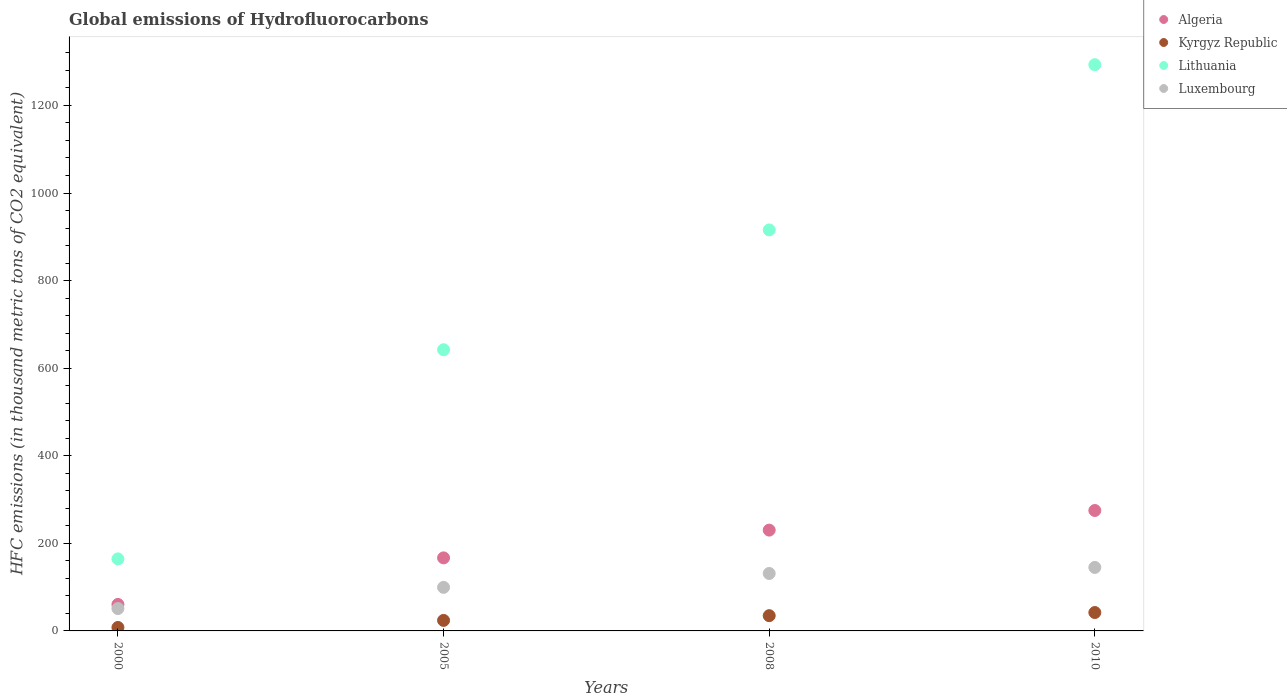Is the number of dotlines equal to the number of legend labels?
Your answer should be very brief. Yes. What is the global emissions of Hydrofluorocarbons in Algeria in 2008?
Make the answer very short. 230.2. Across all years, what is the maximum global emissions of Hydrofluorocarbons in Luxembourg?
Keep it short and to the point. 145. In which year was the global emissions of Hydrofluorocarbons in Luxembourg maximum?
Offer a very short reply. 2010. In which year was the global emissions of Hydrofluorocarbons in Algeria minimum?
Offer a very short reply. 2000. What is the total global emissions of Hydrofluorocarbons in Luxembourg in the graph?
Your response must be concise. 426.8. What is the difference between the global emissions of Hydrofluorocarbons in Kyrgyz Republic in 2000 and that in 2005?
Give a very brief answer. -16.1. What is the difference between the global emissions of Hydrofluorocarbons in Kyrgyz Republic in 2005 and the global emissions of Hydrofluorocarbons in Luxembourg in 2010?
Make the answer very short. -121. What is the average global emissions of Hydrofluorocarbons in Lithuania per year?
Ensure brevity in your answer.  753.83. In the year 2000, what is the difference between the global emissions of Hydrofluorocarbons in Luxembourg and global emissions of Hydrofluorocarbons in Kyrgyz Republic?
Your answer should be very brief. 43.2. In how many years, is the global emissions of Hydrofluorocarbons in Algeria greater than 600 thousand metric tons?
Make the answer very short. 0. What is the ratio of the global emissions of Hydrofluorocarbons in Lithuania in 2000 to that in 2010?
Your answer should be compact. 0.13. Is the global emissions of Hydrofluorocarbons in Luxembourg in 2000 less than that in 2010?
Your answer should be compact. Yes. Is the difference between the global emissions of Hydrofluorocarbons in Luxembourg in 2005 and 2008 greater than the difference between the global emissions of Hydrofluorocarbons in Kyrgyz Republic in 2005 and 2008?
Ensure brevity in your answer.  No. What is the difference between the highest and the second highest global emissions of Hydrofluorocarbons in Algeria?
Make the answer very short. 44.8. What is the difference between the highest and the lowest global emissions of Hydrofluorocarbons in Lithuania?
Provide a succinct answer. 1128.5. In how many years, is the global emissions of Hydrofluorocarbons in Algeria greater than the average global emissions of Hydrofluorocarbons in Algeria taken over all years?
Provide a succinct answer. 2. Is it the case that in every year, the sum of the global emissions of Hydrofluorocarbons in Algeria and global emissions of Hydrofluorocarbons in Kyrgyz Republic  is greater than the sum of global emissions of Hydrofluorocarbons in Lithuania and global emissions of Hydrofluorocarbons in Luxembourg?
Ensure brevity in your answer.  Yes. Is the global emissions of Hydrofluorocarbons in Kyrgyz Republic strictly less than the global emissions of Hydrofluorocarbons in Luxembourg over the years?
Offer a terse response. Yes. How many years are there in the graph?
Offer a terse response. 4. What is the difference between two consecutive major ticks on the Y-axis?
Provide a succinct answer. 200. Are the values on the major ticks of Y-axis written in scientific E-notation?
Provide a short and direct response. No. Does the graph contain grids?
Give a very brief answer. No. Where does the legend appear in the graph?
Make the answer very short. Top right. What is the title of the graph?
Your answer should be compact. Global emissions of Hydrofluorocarbons. What is the label or title of the Y-axis?
Make the answer very short. HFC emissions (in thousand metric tons of CO2 equivalent). What is the HFC emissions (in thousand metric tons of CO2 equivalent) in Algeria in 2000?
Ensure brevity in your answer.  60.5. What is the HFC emissions (in thousand metric tons of CO2 equivalent) in Kyrgyz Republic in 2000?
Offer a very short reply. 7.9. What is the HFC emissions (in thousand metric tons of CO2 equivalent) in Lithuania in 2000?
Offer a terse response. 164.5. What is the HFC emissions (in thousand metric tons of CO2 equivalent) in Luxembourg in 2000?
Ensure brevity in your answer.  51.1. What is the HFC emissions (in thousand metric tons of CO2 equivalent) in Algeria in 2005?
Give a very brief answer. 166.8. What is the HFC emissions (in thousand metric tons of CO2 equivalent) of Lithuania in 2005?
Your answer should be compact. 642.1. What is the HFC emissions (in thousand metric tons of CO2 equivalent) of Luxembourg in 2005?
Keep it short and to the point. 99.5. What is the HFC emissions (in thousand metric tons of CO2 equivalent) of Algeria in 2008?
Your answer should be very brief. 230.2. What is the HFC emissions (in thousand metric tons of CO2 equivalent) of Kyrgyz Republic in 2008?
Make the answer very short. 34.8. What is the HFC emissions (in thousand metric tons of CO2 equivalent) of Lithuania in 2008?
Make the answer very short. 915.7. What is the HFC emissions (in thousand metric tons of CO2 equivalent) in Luxembourg in 2008?
Your answer should be compact. 131.2. What is the HFC emissions (in thousand metric tons of CO2 equivalent) of Algeria in 2010?
Make the answer very short. 275. What is the HFC emissions (in thousand metric tons of CO2 equivalent) in Kyrgyz Republic in 2010?
Your response must be concise. 42. What is the HFC emissions (in thousand metric tons of CO2 equivalent) of Lithuania in 2010?
Your answer should be very brief. 1293. What is the HFC emissions (in thousand metric tons of CO2 equivalent) of Luxembourg in 2010?
Keep it short and to the point. 145. Across all years, what is the maximum HFC emissions (in thousand metric tons of CO2 equivalent) in Algeria?
Ensure brevity in your answer.  275. Across all years, what is the maximum HFC emissions (in thousand metric tons of CO2 equivalent) in Kyrgyz Republic?
Make the answer very short. 42. Across all years, what is the maximum HFC emissions (in thousand metric tons of CO2 equivalent) of Lithuania?
Your answer should be very brief. 1293. Across all years, what is the maximum HFC emissions (in thousand metric tons of CO2 equivalent) of Luxembourg?
Keep it short and to the point. 145. Across all years, what is the minimum HFC emissions (in thousand metric tons of CO2 equivalent) of Algeria?
Provide a succinct answer. 60.5. Across all years, what is the minimum HFC emissions (in thousand metric tons of CO2 equivalent) of Lithuania?
Provide a succinct answer. 164.5. Across all years, what is the minimum HFC emissions (in thousand metric tons of CO2 equivalent) of Luxembourg?
Offer a very short reply. 51.1. What is the total HFC emissions (in thousand metric tons of CO2 equivalent) in Algeria in the graph?
Your answer should be compact. 732.5. What is the total HFC emissions (in thousand metric tons of CO2 equivalent) of Kyrgyz Republic in the graph?
Keep it short and to the point. 108.7. What is the total HFC emissions (in thousand metric tons of CO2 equivalent) in Lithuania in the graph?
Make the answer very short. 3015.3. What is the total HFC emissions (in thousand metric tons of CO2 equivalent) of Luxembourg in the graph?
Make the answer very short. 426.8. What is the difference between the HFC emissions (in thousand metric tons of CO2 equivalent) of Algeria in 2000 and that in 2005?
Offer a very short reply. -106.3. What is the difference between the HFC emissions (in thousand metric tons of CO2 equivalent) in Kyrgyz Republic in 2000 and that in 2005?
Your answer should be very brief. -16.1. What is the difference between the HFC emissions (in thousand metric tons of CO2 equivalent) in Lithuania in 2000 and that in 2005?
Offer a terse response. -477.6. What is the difference between the HFC emissions (in thousand metric tons of CO2 equivalent) of Luxembourg in 2000 and that in 2005?
Offer a terse response. -48.4. What is the difference between the HFC emissions (in thousand metric tons of CO2 equivalent) of Algeria in 2000 and that in 2008?
Keep it short and to the point. -169.7. What is the difference between the HFC emissions (in thousand metric tons of CO2 equivalent) in Kyrgyz Republic in 2000 and that in 2008?
Offer a terse response. -26.9. What is the difference between the HFC emissions (in thousand metric tons of CO2 equivalent) in Lithuania in 2000 and that in 2008?
Make the answer very short. -751.2. What is the difference between the HFC emissions (in thousand metric tons of CO2 equivalent) in Luxembourg in 2000 and that in 2008?
Offer a very short reply. -80.1. What is the difference between the HFC emissions (in thousand metric tons of CO2 equivalent) of Algeria in 2000 and that in 2010?
Provide a short and direct response. -214.5. What is the difference between the HFC emissions (in thousand metric tons of CO2 equivalent) in Kyrgyz Republic in 2000 and that in 2010?
Give a very brief answer. -34.1. What is the difference between the HFC emissions (in thousand metric tons of CO2 equivalent) of Lithuania in 2000 and that in 2010?
Keep it short and to the point. -1128.5. What is the difference between the HFC emissions (in thousand metric tons of CO2 equivalent) of Luxembourg in 2000 and that in 2010?
Your answer should be compact. -93.9. What is the difference between the HFC emissions (in thousand metric tons of CO2 equivalent) in Algeria in 2005 and that in 2008?
Provide a succinct answer. -63.4. What is the difference between the HFC emissions (in thousand metric tons of CO2 equivalent) of Lithuania in 2005 and that in 2008?
Provide a succinct answer. -273.6. What is the difference between the HFC emissions (in thousand metric tons of CO2 equivalent) of Luxembourg in 2005 and that in 2008?
Your answer should be compact. -31.7. What is the difference between the HFC emissions (in thousand metric tons of CO2 equivalent) of Algeria in 2005 and that in 2010?
Your answer should be compact. -108.2. What is the difference between the HFC emissions (in thousand metric tons of CO2 equivalent) in Lithuania in 2005 and that in 2010?
Your answer should be very brief. -650.9. What is the difference between the HFC emissions (in thousand metric tons of CO2 equivalent) of Luxembourg in 2005 and that in 2010?
Your answer should be very brief. -45.5. What is the difference between the HFC emissions (in thousand metric tons of CO2 equivalent) in Algeria in 2008 and that in 2010?
Keep it short and to the point. -44.8. What is the difference between the HFC emissions (in thousand metric tons of CO2 equivalent) in Lithuania in 2008 and that in 2010?
Provide a short and direct response. -377.3. What is the difference between the HFC emissions (in thousand metric tons of CO2 equivalent) of Algeria in 2000 and the HFC emissions (in thousand metric tons of CO2 equivalent) of Kyrgyz Republic in 2005?
Provide a succinct answer. 36.5. What is the difference between the HFC emissions (in thousand metric tons of CO2 equivalent) in Algeria in 2000 and the HFC emissions (in thousand metric tons of CO2 equivalent) in Lithuania in 2005?
Make the answer very short. -581.6. What is the difference between the HFC emissions (in thousand metric tons of CO2 equivalent) in Algeria in 2000 and the HFC emissions (in thousand metric tons of CO2 equivalent) in Luxembourg in 2005?
Provide a succinct answer. -39. What is the difference between the HFC emissions (in thousand metric tons of CO2 equivalent) of Kyrgyz Republic in 2000 and the HFC emissions (in thousand metric tons of CO2 equivalent) of Lithuania in 2005?
Your answer should be compact. -634.2. What is the difference between the HFC emissions (in thousand metric tons of CO2 equivalent) in Kyrgyz Republic in 2000 and the HFC emissions (in thousand metric tons of CO2 equivalent) in Luxembourg in 2005?
Make the answer very short. -91.6. What is the difference between the HFC emissions (in thousand metric tons of CO2 equivalent) of Lithuania in 2000 and the HFC emissions (in thousand metric tons of CO2 equivalent) of Luxembourg in 2005?
Keep it short and to the point. 65. What is the difference between the HFC emissions (in thousand metric tons of CO2 equivalent) of Algeria in 2000 and the HFC emissions (in thousand metric tons of CO2 equivalent) of Kyrgyz Republic in 2008?
Offer a terse response. 25.7. What is the difference between the HFC emissions (in thousand metric tons of CO2 equivalent) of Algeria in 2000 and the HFC emissions (in thousand metric tons of CO2 equivalent) of Lithuania in 2008?
Make the answer very short. -855.2. What is the difference between the HFC emissions (in thousand metric tons of CO2 equivalent) in Algeria in 2000 and the HFC emissions (in thousand metric tons of CO2 equivalent) in Luxembourg in 2008?
Provide a succinct answer. -70.7. What is the difference between the HFC emissions (in thousand metric tons of CO2 equivalent) of Kyrgyz Republic in 2000 and the HFC emissions (in thousand metric tons of CO2 equivalent) of Lithuania in 2008?
Ensure brevity in your answer.  -907.8. What is the difference between the HFC emissions (in thousand metric tons of CO2 equivalent) of Kyrgyz Republic in 2000 and the HFC emissions (in thousand metric tons of CO2 equivalent) of Luxembourg in 2008?
Make the answer very short. -123.3. What is the difference between the HFC emissions (in thousand metric tons of CO2 equivalent) of Lithuania in 2000 and the HFC emissions (in thousand metric tons of CO2 equivalent) of Luxembourg in 2008?
Provide a succinct answer. 33.3. What is the difference between the HFC emissions (in thousand metric tons of CO2 equivalent) in Algeria in 2000 and the HFC emissions (in thousand metric tons of CO2 equivalent) in Lithuania in 2010?
Make the answer very short. -1232.5. What is the difference between the HFC emissions (in thousand metric tons of CO2 equivalent) of Algeria in 2000 and the HFC emissions (in thousand metric tons of CO2 equivalent) of Luxembourg in 2010?
Your response must be concise. -84.5. What is the difference between the HFC emissions (in thousand metric tons of CO2 equivalent) of Kyrgyz Republic in 2000 and the HFC emissions (in thousand metric tons of CO2 equivalent) of Lithuania in 2010?
Your answer should be compact. -1285.1. What is the difference between the HFC emissions (in thousand metric tons of CO2 equivalent) in Kyrgyz Republic in 2000 and the HFC emissions (in thousand metric tons of CO2 equivalent) in Luxembourg in 2010?
Your answer should be compact. -137.1. What is the difference between the HFC emissions (in thousand metric tons of CO2 equivalent) of Algeria in 2005 and the HFC emissions (in thousand metric tons of CO2 equivalent) of Kyrgyz Republic in 2008?
Your response must be concise. 132. What is the difference between the HFC emissions (in thousand metric tons of CO2 equivalent) in Algeria in 2005 and the HFC emissions (in thousand metric tons of CO2 equivalent) in Lithuania in 2008?
Your answer should be compact. -748.9. What is the difference between the HFC emissions (in thousand metric tons of CO2 equivalent) of Algeria in 2005 and the HFC emissions (in thousand metric tons of CO2 equivalent) of Luxembourg in 2008?
Offer a terse response. 35.6. What is the difference between the HFC emissions (in thousand metric tons of CO2 equivalent) in Kyrgyz Republic in 2005 and the HFC emissions (in thousand metric tons of CO2 equivalent) in Lithuania in 2008?
Provide a short and direct response. -891.7. What is the difference between the HFC emissions (in thousand metric tons of CO2 equivalent) of Kyrgyz Republic in 2005 and the HFC emissions (in thousand metric tons of CO2 equivalent) of Luxembourg in 2008?
Make the answer very short. -107.2. What is the difference between the HFC emissions (in thousand metric tons of CO2 equivalent) of Lithuania in 2005 and the HFC emissions (in thousand metric tons of CO2 equivalent) of Luxembourg in 2008?
Offer a terse response. 510.9. What is the difference between the HFC emissions (in thousand metric tons of CO2 equivalent) of Algeria in 2005 and the HFC emissions (in thousand metric tons of CO2 equivalent) of Kyrgyz Republic in 2010?
Your response must be concise. 124.8. What is the difference between the HFC emissions (in thousand metric tons of CO2 equivalent) in Algeria in 2005 and the HFC emissions (in thousand metric tons of CO2 equivalent) in Lithuania in 2010?
Offer a terse response. -1126.2. What is the difference between the HFC emissions (in thousand metric tons of CO2 equivalent) of Algeria in 2005 and the HFC emissions (in thousand metric tons of CO2 equivalent) of Luxembourg in 2010?
Your answer should be very brief. 21.8. What is the difference between the HFC emissions (in thousand metric tons of CO2 equivalent) in Kyrgyz Republic in 2005 and the HFC emissions (in thousand metric tons of CO2 equivalent) in Lithuania in 2010?
Your answer should be compact. -1269. What is the difference between the HFC emissions (in thousand metric tons of CO2 equivalent) in Kyrgyz Republic in 2005 and the HFC emissions (in thousand metric tons of CO2 equivalent) in Luxembourg in 2010?
Your answer should be very brief. -121. What is the difference between the HFC emissions (in thousand metric tons of CO2 equivalent) of Lithuania in 2005 and the HFC emissions (in thousand metric tons of CO2 equivalent) of Luxembourg in 2010?
Your response must be concise. 497.1. What is the difference between the HFC emissions (in thousand metric tons of CO2 equivalent) in Algeria in 2008 and the HFC emissions (in thousand metric tons of CO2 equivalent) in Kyrgyz Republic in 2010?
Make the answer very short. 188.2. What is the difference between the HFC emissions (in thousand metric tons of CO2 equivalent) of Algeria in 2008 and the HFC emissions (in thousand metric tons of CO2 equivalent) of Lithuania in 2010?
Offer a very short reply. -1062.8. What is the difference between the HFC emissions (in thousand metric tons of CO2 equivalent) in Algeria in 2008 and the HFC emissions (in thousand metric tons of CO2 equivalent) in Luxembourg in 2010?
Your answer should be compact. 85.2. What is the difference between the HFC emissions (in thousand metric tons of CO2 equivalent) of Kyrgyz Republic in 2008 and the HFC emissions (in thousand metric tons of CO2 equivalent) of Lithuania in 2010?
Keep it short and to the point. -1258.2. What is the difference between the HFC emissions (in thousand metric tons of CO2 equivalent) in Kyrgyz Republic in 2008 and the HFC emissions (in thousand metric tons of CO2 equivalent) in Luxembourg in 2010?
Your answer should be very brief. -110.2. What is the difference between the HFC emissions (in thousand metric tons of CO2 equivalent) of Lithuania in 2008 and the HFC emissions (in thousand metric tons of CO2 equivalent) of Luxembourg in 2010?
Keep it short and to the point. 770.7. What is the average HFC emissions (in thousand metric tons of CO2 equivalent) of Algeria per year?
Provide a short and direct response. 183.12. What is the average HFC emissions (in thousand metric tons of CO2 equivalent) in Kyrgyz Republic per year?
Keep it short and to the point. 27.18. What is the average HFC emissions (in thousand metric tons of CO2 equivalent) of Lithuania per year?
Offer a terse response. 753.83. What is the average HFC emissions (in thousand metric tons of CO2 equivalent) in Luxembourg per year?
Your answer should be compact. 106.7. In the year 2000, what is the difference between the HFC emissions (in thousand metric tons of CO2 equivalent) of Algeria and HFC emissions (in thousand metric tons of CO2 equivalent) of Kyrgyz Republic?
Your answer should be compact. 52.6. In the year 2000, what is the difference between the HFC emissions (in thousand metric tons of CO2 equivalent) of Algeria and HFC emissions (in thousand metric tons of CO2 equivalent) of Lithuania?
Provide a succinct answer. -104. In the year 2000, what is the difference between the HFC emissions (in thousand metric tons of CO2 equivalent) of Kyrgyz Republic and HFC emissions (in thousand metric tons of CO2 equivalent) of Lithuania?
Make the answer very short. -156.6. In the year 2000, what is the difference between the HFC emissions (in thousand metric tons of CO2 equivalent) of Kyrgyz Republic and HFC emissions (in thousand metric tons of CO2 equivalent) of Luxembourg?
Provide a succinct answer. -43.2. In the year 2000, what is the difference between the HFC emissions (in thousand metric tons of CO2 equivalent) of Lithuania and HFC emissions (in thousand metric tons of CO2 equivalent) of Luxembourg?
Provide a succinct answer. 113.4. In the year 2005, what is the difference between the HFC emissions (in thousand metric tons of CO2 equivalent) of Algeria and HFC emissions (in thousand metric tons of CO2 equivalent) of Kyrgyz Republic?
Ensure brevity in your answer.  142.8. In the year 2005, what is the difference between the HFC emissions (in thousand metric tons of CO2 equivalent) of Algeria and HFC emissions (in thousand metric tons of CO2 equivalent) of Lithuania?
Offer a very short reply. -475.3. In the year 2005, what is the difference between the HFC emissions (in thousand metric tons of CO2 equivalent) in Algeria and HFC emissions (in thousand metric tons of CO2 equivalent) in Luxembourg?
Offer a very short reply. 67.3. In the year 2005, what is the difference between the HFC emissions (in thousand metric tons of CO2 equivalent) in Kyrgyz Republic and HFC emissions (in thousand metric tons of CO2 equivalent) in Lithuania?
Your answer should be compact. -618.1. In the year 2005, what is the difference between the HFC emissions (in thousand metric tons of CO2 equivalent) of Kyrgyz Republic and HFC emissions (in thousand metric tons of CO2 equivalent) of Luxembourg?
Your response must be concise. -75.5. In the year 2005, what is the difference between the HFC emissions (in thousand metric tons of CO2 equivalent) in Lithuania and HFC emissions (in thousand metric tons of CO2 equivalent) in Luxembourg?
Your response must be concise. 542.6. In the year 2008, what is the difference between the HFC emissions (in thousand metric tons of CO2 equivalent) in Algeria and HFC emissions (in thousand metric tons of CO2 equivalent) in Kyrgyz Republic?
Keep it short and to the point. 195.4. In the year 2008, what is the difference between the HFC emissions (in thousand metric tons of CO2 equivalent) in Algeria and HFC emissions (in thousand metric tons of CO2 equivalent) in Lithuania?
Provide a succinct answer. -685.5. In the year 2008, what is the difference between the HFC emissions (in thousand metric tons of CO2 equivalent) in Kyrgyz Republic and HFC emissions (in thousand metric tons of CO2 equivalent) in Lithuania?
Keep it short and to the point. -880.9. In the year 2008, what is the difference between the HFC emissions (in thousand metric tons of CO2 equivalent) of Kyrgyz Republic and HFC emissions (in thousand metric tons of CO2 equivalent) of Luxembourg?
Your answer should be compact. -96.4. In the year 2008, what is the difference between the HFC emissions (in thousand metric tons of CO2 equivalent) in Lithuania and HFC emissions (in thousand metric tons of CO2 equivalent) in Luxembourg?
Give a very brief answer. 784.5. In the year 2010, what is the difference between the HFC emissions (in thousand metric tons of CO2 equivalent) in Algeria and HFC emissions (in thousand metric tons of CO2 equivalent) in Kyrgyz Republic?
Your answer should be compact. 233. In the year 2010, what is the difference between the HFC emissions (in thousand metric tons of CO2 equivalent) of Algeria and HFC emissions (in thousand metric tons of CO2 equivalent) of Lithuania?
Keep it short and to the point. -1018. In the year 2010, what is the difference between the HFC emissions (in thousand metric tons of CO2 equivalent) in Algeria and HFC emissions (in thousand metric tons of CO2 equivalent) in Luxembourg?
Provide a succinct answer. 130. In the year 2010, what is the difference between the HFC emissions (in thousand metric tons of CO2 equivalent) in Kyrgyz Republic and HFC emissions (in thousand metric tons of CO2 equivalent) in Lithuania?
Ensure brevity in your answer.  -1251. In the year 2010, what is the difference between the HFC emissions (in thousand metric tons of CO2 equivalent) in Kyrgyz Republic and HFC emissions (in thousand metric tons of CO2 equivalent) in Luxembourg?
Offer a very short reply. -103. In the year 2010, what is the difference between the HFC emissions (in thousand metric tons of CO2 equivalent) of Lithuania and HFC emissions (in thousand metric tons of CO2 equivalent) of Luxembourg?
Keep it short and to the point. 1148. What is the ratio of the HFC emissions (in thousand metric tons of CO2 equivalent) in Algeria in 2000 to that in 2005?
Offer a terse response. 0.36. What is the ratio of the HFC emissions (in thousand metric tons of CO2 equivalent) of Kyrgyz Republic in 2000 to that in 2005?
Ensure brevity in your answer.  0.33. What is the ratio of the HFC emissions (in thousand metric tons of CO2 equivalent) in Lithuania in 2000 to that in 2005?
Make the answer very short. 0.26. What is the ratio of the HFC emissions (in thousand metric tons of CO2 equivalent) of Luxembourg in 2000 to that in 2005?
Your answer should be very brief. 0.51. What is the ratio of the HFC emissions (in thousand metric tons of CO2 equivalent) in Algeria in 2000 to that in 2008?
Give a very brief answer. 0.26. What is the ratio of the HFC emissions (in thousand metric tons of CO2 equivalent) in Kyrgyz Republic in 2000 to that in 2008?
Keep it short and to the point. 0.23. What is the ratio of the HFC emissions (in thousand metric tons of CO2 equivalent) of Lithuania in 2000 to that in 2008?
Your answer should be compact. 0.18. What is the ratio of the HFC emissions (in thousand metric tons of CO2 equivalent) of Luxembourg in 2000 to that in 2008?
Your answer should be very brief. 0.39. What is the ratio of the HFC emissions (in thousand metric tons of CO2 equivalent) in Algeria in 2000 to that in 2010?
Your response must be concise. 0.22. What is the ratio of the HFC emissions (in thousand metric tons of CO2 equivalent) of Kyrgyz Republic in 2000 to that in 2010?
Your answer should be compact. 0.19. What is the ratio of the HFC emissions (in thousand metric tons of CO2 equivalent) in Lithuania in 2000 to that in 2010?
Offer a terse response. 0.13. What is the ratio of the HFC emissions (in thousand metric tons of CO2 equivalent) in Luxembourg in 2000 to that in 2010?
Provide a succinct answer. 0.35. What is the ratio of the HFC emissions (in thousand metric tons of CO2 equivalent) of Algeria in 2005 to that in 2008?
Offer a terse response. 0.72. What is the ratio of the HFC emissions (in thousand metric tons of CO2 equivalent) in Kyrgyz Republic in 2005 to that in 2008?
Keep it short and to the point. 0.69. What is the ratio of the HFC emissions (in thousand metric tons of CO2 equivalent) of Lithuania in 2005 to that in 2008?
Offer a terse response. 0.7. What is the ratio of the HFC emissions (in thousand metric tons of CO2 equivalent) in Luxembourg in 2005 to that in 2008?
Your response must be concise. 0.76. What is the ratio of the HFC emissions (in thousand metric tons of CO2 equivalent) in Algeria in 2005 to that in 2010?
Your response must be concise. 0.61. What is the ratio of the HFC emissions (in thousand metric tons of CO2 equivalent) in Lithuania in 2005 to that in 2010?
Make the answer very short. 0.5. What is the ratio of the HFC emissions (in thousand metric tons of CO2 equivalent) of Luxembourg in 2005 to that in 2010?
Offer a very short reply. 0.69. What is the ratio of the HFC emissions (in thousand metric tons of CO2 equivalent) of Algeria in 2008 to that in 2010?
Your answer should be very brief. 0.84. What is the ratio of the HFC emissions (in thousand metric tons of CO2 equivalent) in Kyrgyz Republic in 2008 to that in 2010?
Your response must be concise. 0.83. What is the ratio of the HFC emissions (in thousand metric tons of CO2 equivalent) of Lithuania in 2008 to that in 2010?
Make the answer very short. 0.71. What is the ratio of the HFC emissions (in thousand metric tons of CO2 equivalent) in Luxembourg in 2008 to that in 2010?
Keep it short and to the point. 0.9. What is the difference between the highest and the second highest HFC emissions (in thousand metric tons of CO2 equivalent) in Algeria?
Offer a very short reply. 44.8. What is the difference between the highest and the second highest HFC emissions (in thousand metric tons of CO2 equivalent) in Kyrgyz Republic?
Your answer should be very brief. 7.2. What is the difference between the highest and the second highest HFC emissions (in thousand metric tons of CO2 equivalent) in Lithuania?
Your answer should be very brief. 377.3. What is the difference between the highest and the second highest HFC emissions (in thousand metric tons of CO2 equivalent) of Luxembourg?
Ensure brevity in your answer.  13.8. What is the difference between the highest and the lowest HFC emissions (in thousand metric tons of CO2 equivalent) of Algeria?
Ensure brevity in your answer.  214.5. What is the difference between the highest and the lowest HFC emissions (in thousand metric tons of CO2 equivalent) in Kyrgyz Republic?
Ensure brevity in your answer.  34.1. What is the difference between the highest and the lowest HFC emissions (in thousand metric tons of CO2 equivalent) in Lithuania?
Give a very brief answer. 1128.5. What is the difference between the highest and the lowest HFC emissions (in thousand metric tons of CO2 equivalent) in Luxembourg?
Provide a short and direct response. 93.9. 